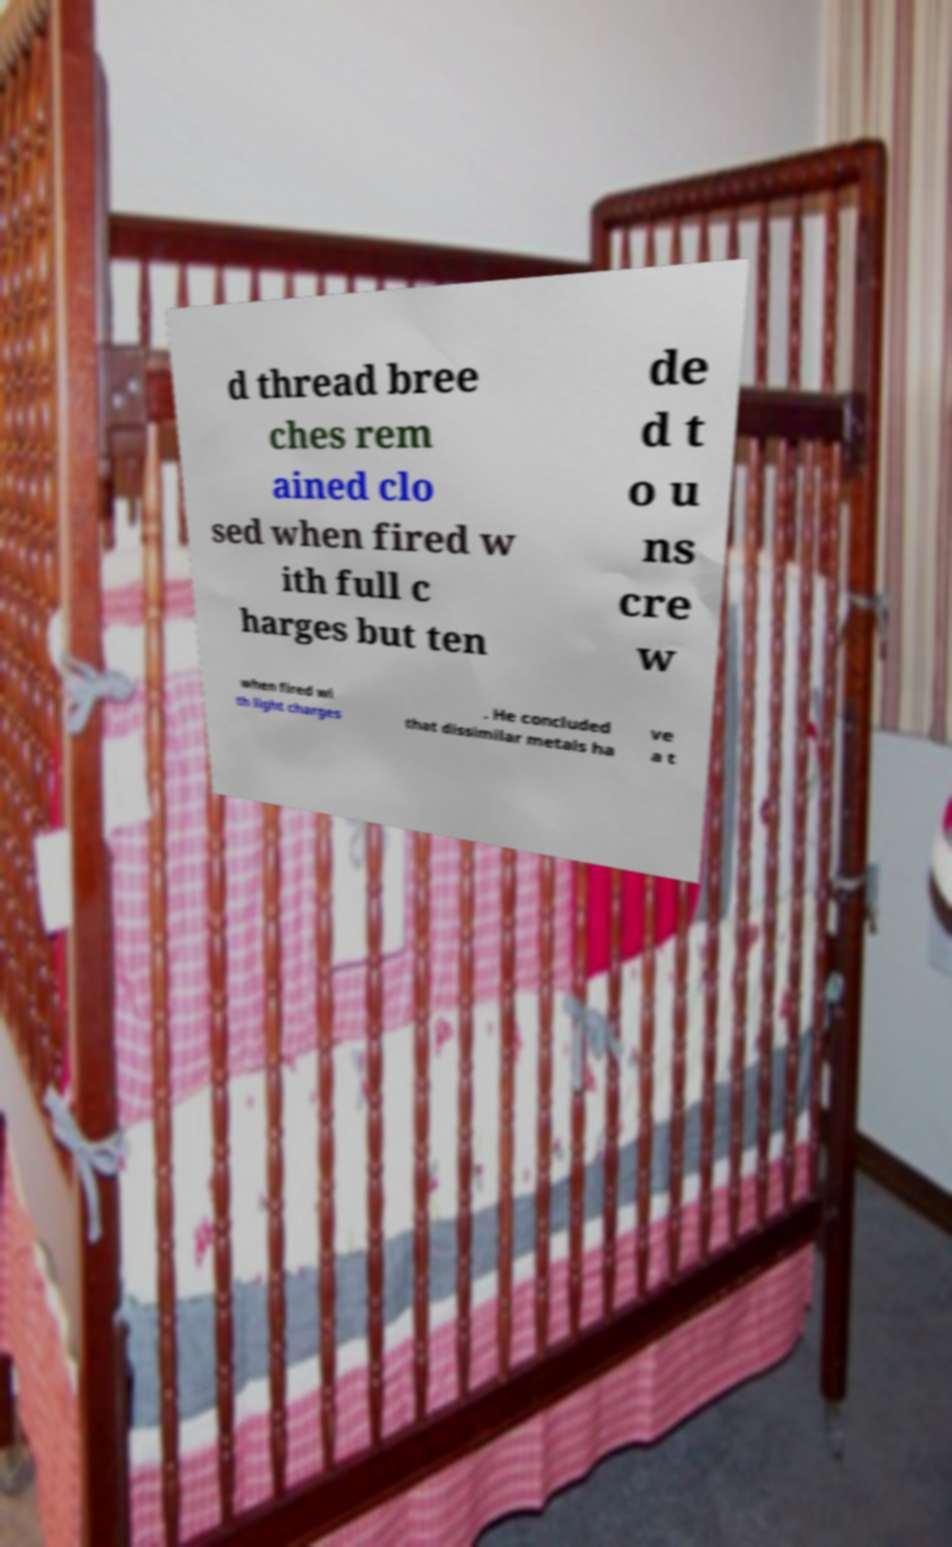There's text embedded in this image that I need extracted. Can you transcribe it verbatim? d thread bree ches rem ained clo sed when fired w ith full c harges but ten de d t o u ns cre w when fired wi th light charges . He concluded that dissimilar metals ha ve a t 